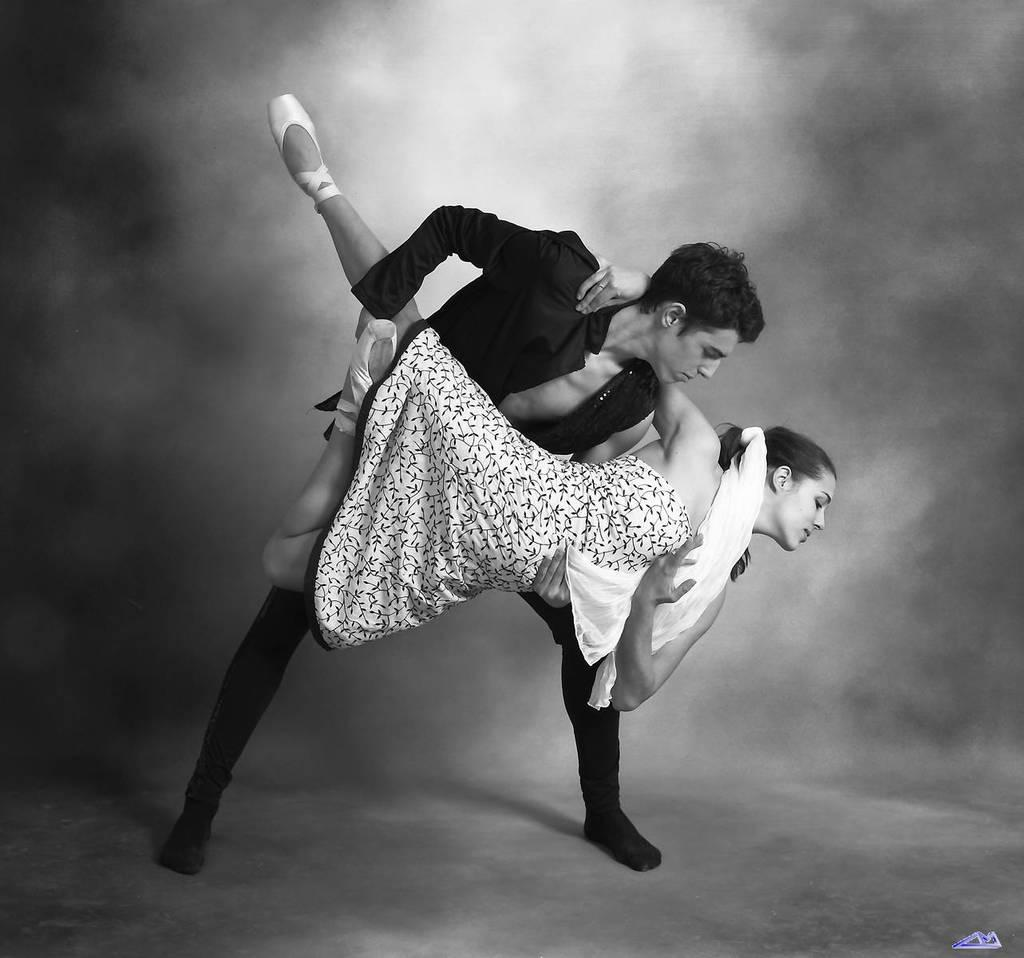What is the color scheme of the image? The image is black and white. What is happening between the man and the woman in the image? The man is holding the woman in the image. What can be seen in the background of the image? There is smoke in the background of the image. What is located at the bottom of the image? There is a logo at the bottom of the image. What type of mint is being used to express hate in the image? There is no mint present in the image, nor is there any indication of hate or fighting. 